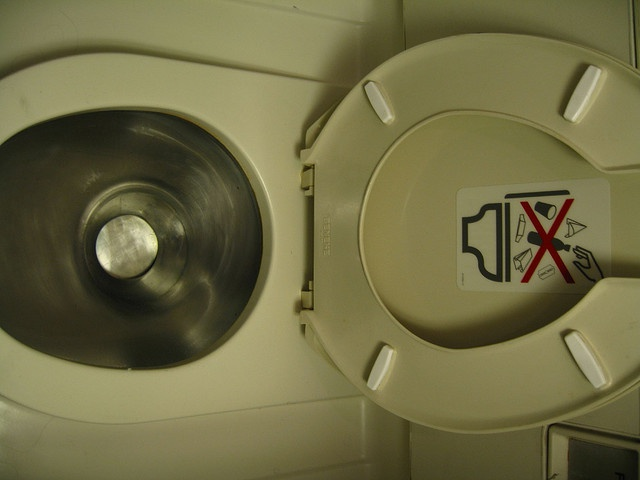Describe the objects in this image and their specific colors. I can see a toilet in darkgreen, olive, and black tones in this image. 